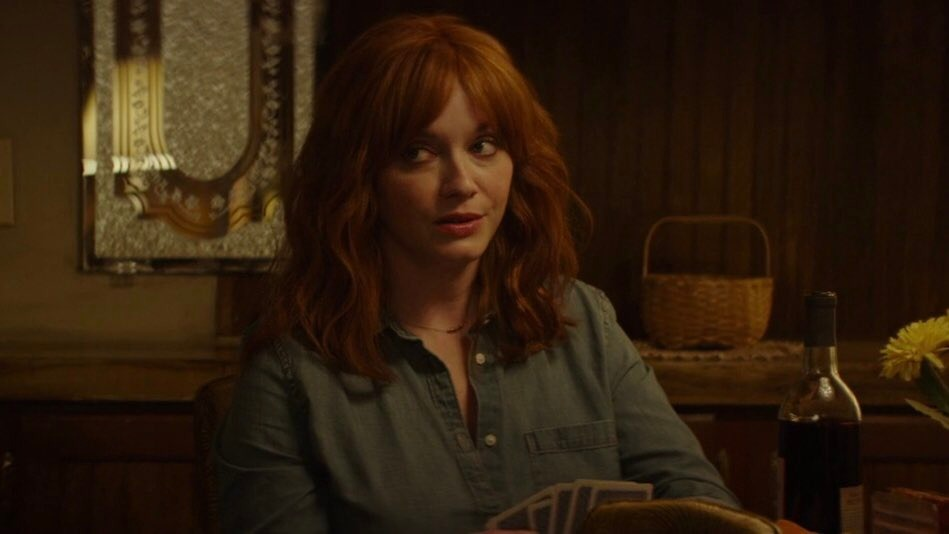If you could add one mystical element to this picture, what would it be? Imagine a soft, ethereal glow emanating from the yellow flowers in the vase. This magical aura illuminates the room with a gentle, otherworldly light. The flowers slowly open and reveal tiny, luminous fairies that flutter around the woman, offering whispers of wisdom and insight. This transformation brings a sense of enchantment to the scene, suggesting that the answers she seeks might just come from these mystical beings. 